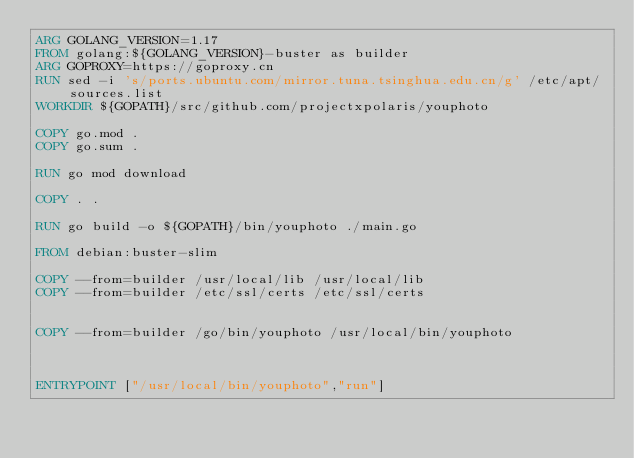Convert code to text. <code><loc_0><loc_0><loc_500><loc_500><_Dockerfile_>ARG GOLANG_VERSION=1.17
FROM golang:${GOLANG_VERSION}-buster as builder
ARG GOPROXY=https://goproxy.cn
RUN sed -i 's/ports.ubuntu.com/mirror.tuna.tsinghua.edu.cn/g' /etc/apt/sources.list
WORKDIR ${GOPATH}/src/github.com/projectxpolaris/youphoto

COPY go.mod .
COPY go.sum .

RUN go mod download

COPY . .

RUN go build -o ${GOPATH}/bin/youphoto ./main.go

FROM debian:buster-slim

COPY --from=builder /usr/local/lib /usr/local/lib
COPY --from=builder /etc/ssl/certs /etc/ssl/certs


COPY --from=builder /go/bin/youphoto /usr/local/bin/youphoto



ENTRYPOINT ["/usr/local/bin/youphoto","run"]

</code> 